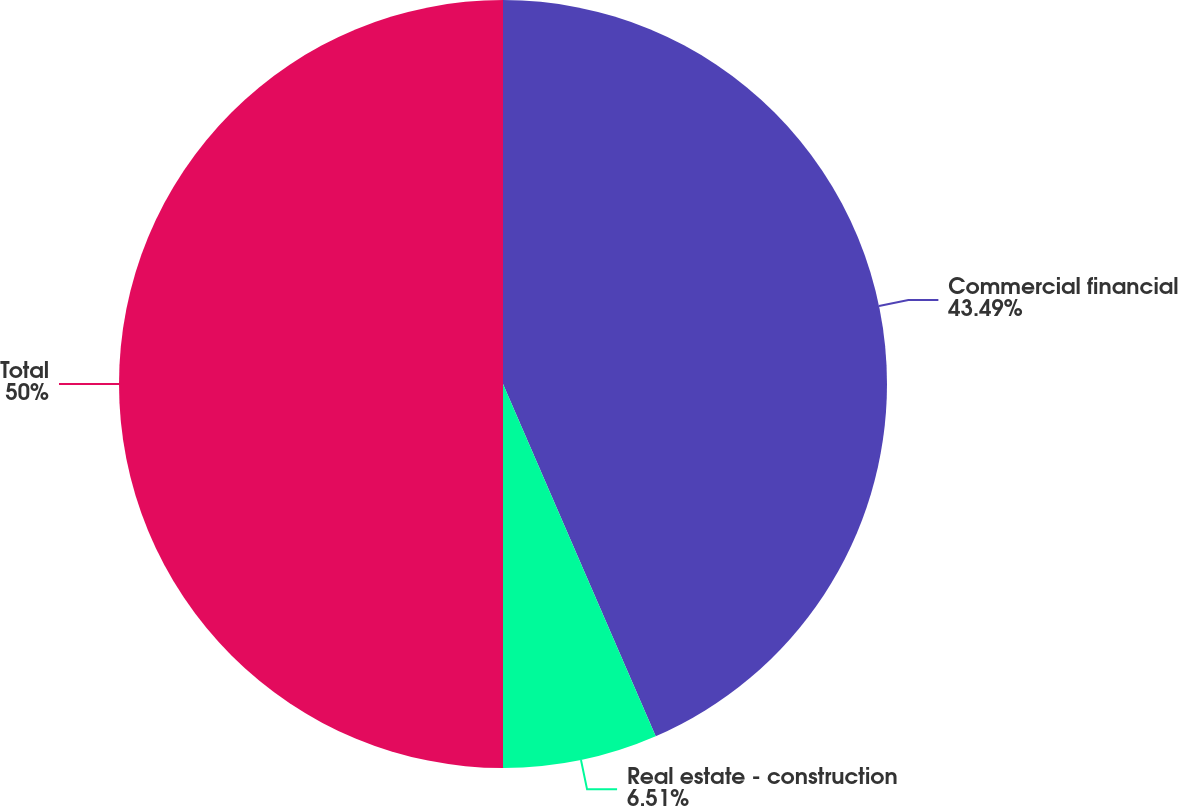<chart> <loc_0><loc_0><loc_500><loc_500><pie_chart><fcel>Commercial financial<fcel>Real estate - construction<fcel>Total<nl><fcel>43.49%<fcel>6.51%<fcel>50.0%<nl></chart> 